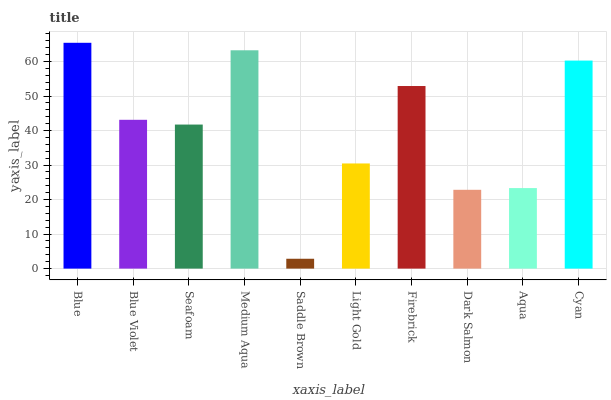Is Saddle Brown the minimum?
Answer yes or no. Yes. Is Blue the maximum?
Answer yes or no. Yes. Is Blue Violet the minimum?
Answer yes or no. No. Is Blue Violet the maximum?
Answer yes or no. No. Is Blue greater than Blue Violet?
Answer yes or no. Yes. Is Blue Violet less than Blue?
Answer yes or no. Yes. Is Blue Violet greater than Blue?
Answer yes or no. No. Is Blue less than Blue Violet?
Answer yes or no. No. Is Blue Violet the high median?
Answer yes or no. Yes. Is Seafoam the low median?
Answer yes or no. Yes. Is Aqua the high median?
Answer yes or no. No. Is Medium Aqua the low median?
Answer yes or no. No. 